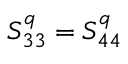Convert formula to latex. <formula><loc_0><loc_0><loc_500><loc_500>S _ { 3 3 } ^ { q } = S _ { 4 4 } ^ { q }</formula> 